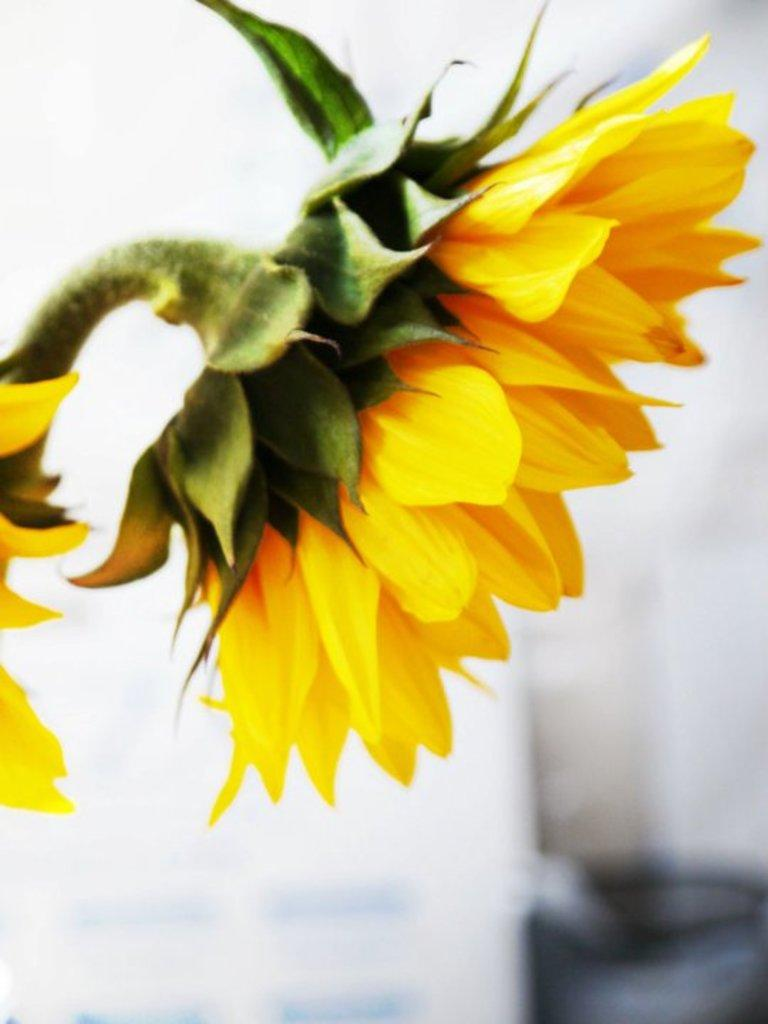How many flowers are visible in the image? There are two flowers in the image. What can be seen behind the flowers? There are objects behind the flowers. What type of stocking is being worn by the muscle in the image? There is no muscle or stocking present in the image; it only features two flowers and objects behind them. 